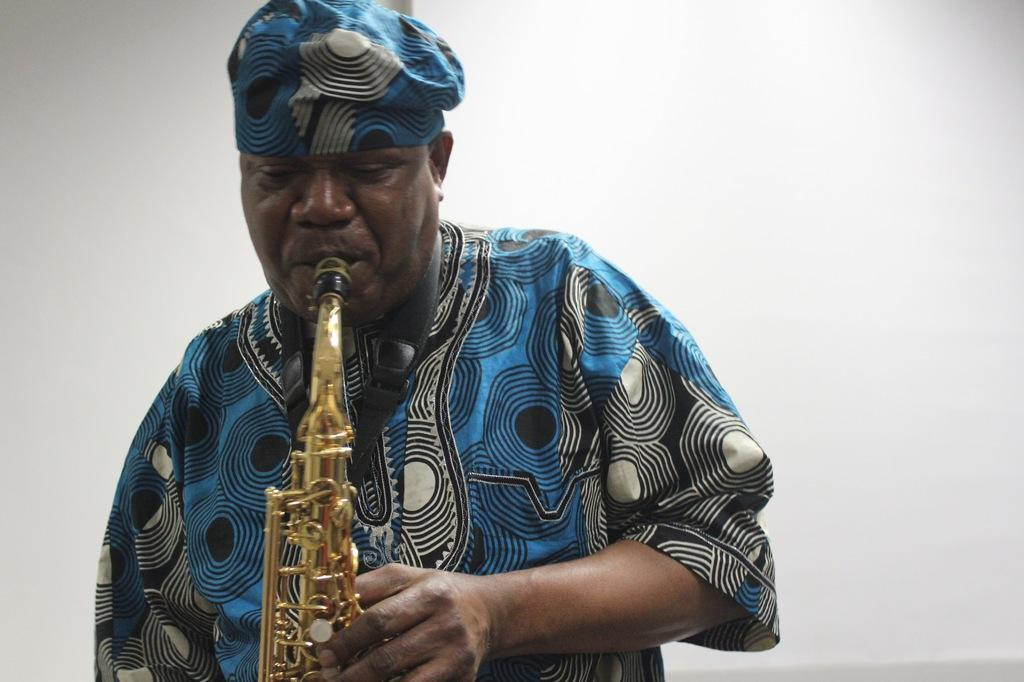What is the person in the image doing? The person is playing a musical instrument in the image. What can be seen in the background of the image? There is a wall in the background of the image. What type of game is being played on the wall in the image? There is no game being played on the wall in the image; it is just a background element. 